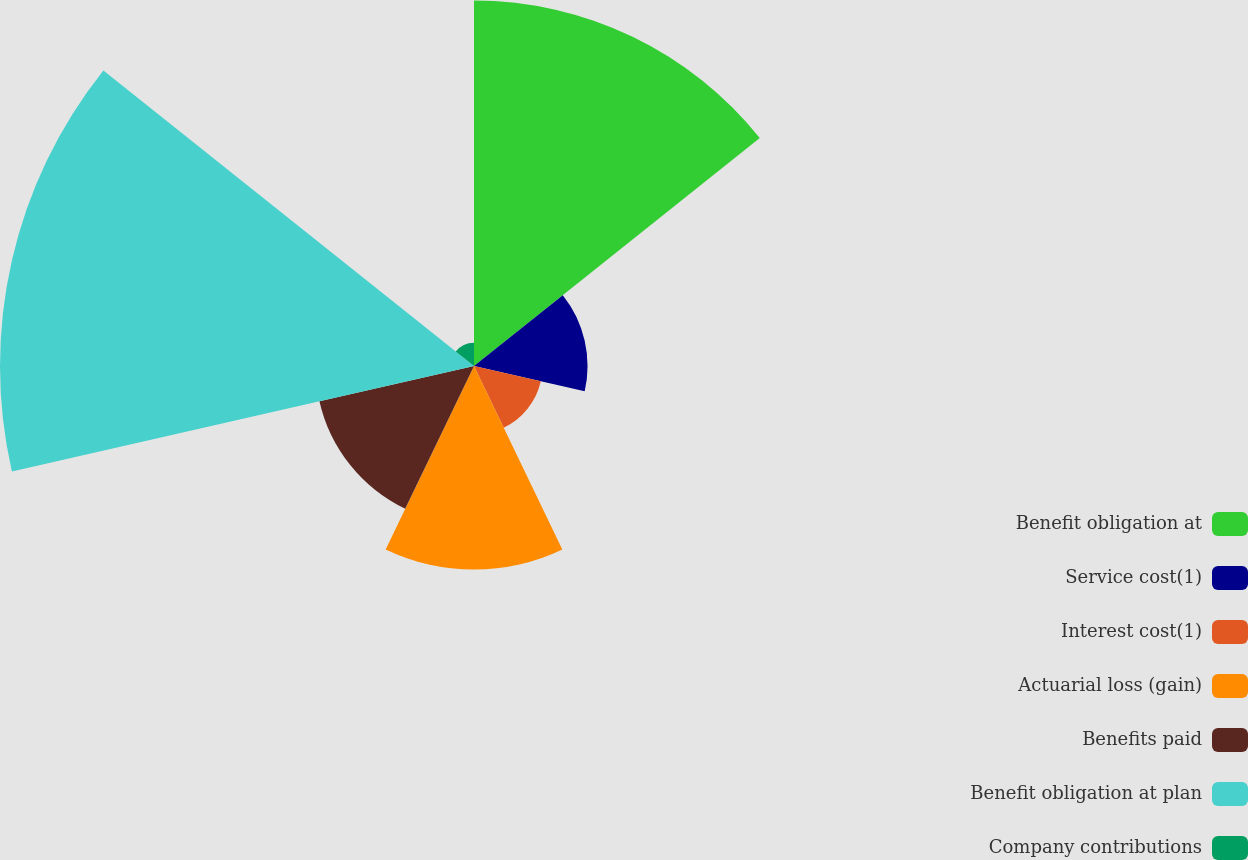Convert chart to OTSL. <chart><loc_0><loc_0><loc_500><loc_500><pie_chart><fcel>Benefit obligation at<fcel>Service cost(1)<fcel>Interest cost(1)<fcel>Actuarial loss (gain)<fcel>Benefits paid<fcel>Benefit obligation at plan<fcel>Company contributions<nl><fcel>25.98%<fcel>8.07%<fcel>4.87%<fcel>14.47%<fcel>11.27%<fcel>33.69%<fcel>1.66%<nl></chart> 